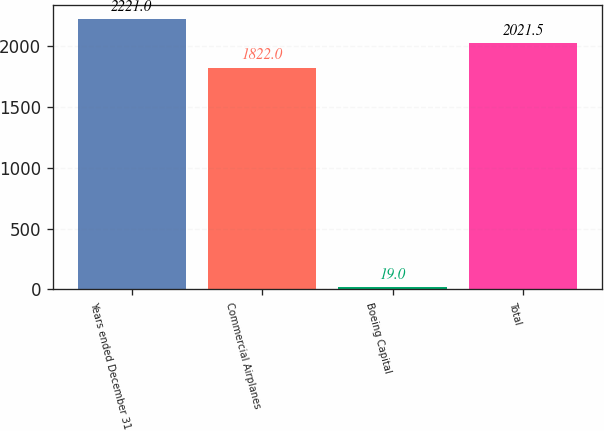Convert chart. <chart><loc_0><loc_0><loc_500><loc_500><bar_chart><fcel>Years ended December 31<fcel>Commercial Airplanes<fcel>Boeing Capital<fcel>Total<nl><fcel>2221<fcel>1822<fcel>19<fcel>2021.5<nl></chart> 